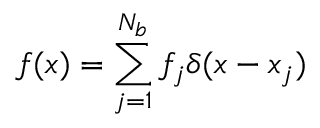<formula> <loc_0><loc_0><loc_500><loc_500>f ( \boldsymbol x ) = \sum _ { j = 1 } ^ { N _ { b } } f _ { j } \delta ( \boldsymbol x - \boldsymbol x _ { j } )</formula> 